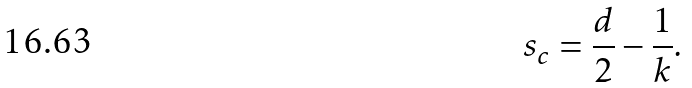Convert formula to latex. <formula><loc_0><loc_0><loc_500><loc_500>s _ { c } = \frac { d } { 2 } - \frac { 1 } { k } .</formula> 